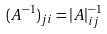<formula> <loc_0><loc_0><loc_500><loc_500>( A ^ { - 1 } ) _ { j i } = | A | _ { i j } ^ { - 1 }</formula> 